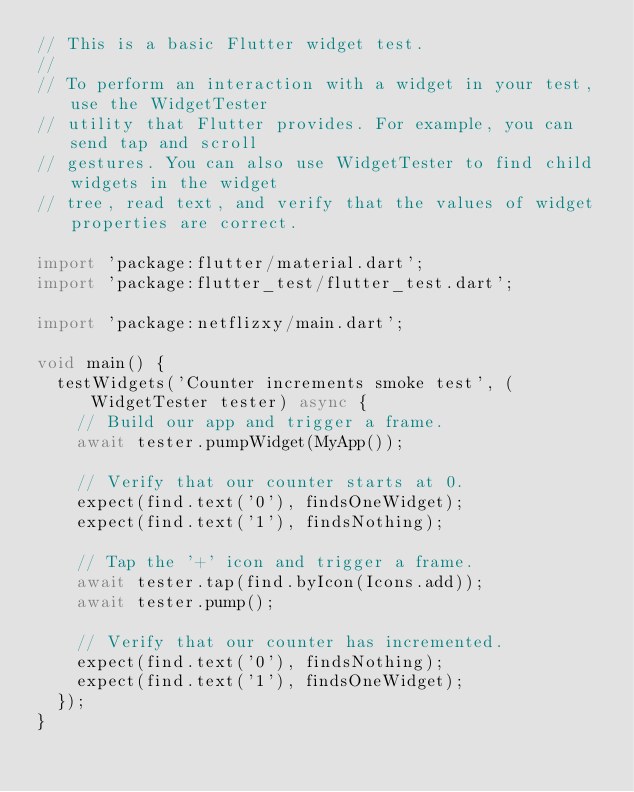Convert code to text. <code><loc_0><loc_0><loc_500><loc_500><_Dart_>// This is a basic Flutter widget test.
//
// To perform an interaction with a widget in your test, use the WidgetTester
// utility that Flutter provides. For example, you can send tap and scroll
// gestures. You can also use WidgetTester to find child widgets in the widget
// tree, read text, and verify that the values of widget properties are correct.

import 'package:flutter/material.dart';
import 'package:flutter_test/flutter_test.dart';

import 'package:netflizxy/main.dart';

void main() {
  testWidgets('Counter increments smoke test', (WidgetTester tester) async {
    // Build our app and trigger a frame.
    await tester.pumpWidget(MyApp());

    // Verify that our counter starts at 0.
    expect(find.text('0'), findsOneWidget);
    expect(find.text('1'), findsNothing);

    // Tap the '+' icon and trigger a frame.
    await tester.tap(find.byIcon(Icons.add));
    await tester.pump();

    // Verify that our counter has incremented.
    expect(find.text('0'), findsNothing);
    expect(find.text('1'), findsOneWidget);
  });
}
</code> 